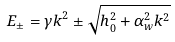Convert formula to latex. <formula><loc_0><loc_0><loc_500><loc_500>E _ { \pm } = \gamma k ^ { 2 } \pm \sqrt { h _ { 0 } ^ { 2 } + \alpha _ { w } ^ { 2 } k ^ { 2 } }</formula> 